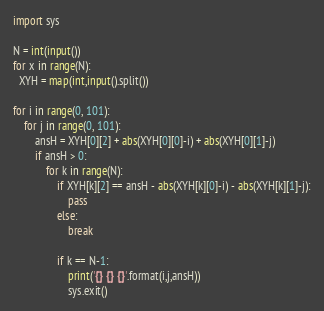Convert code to text. <code><loc_0><loc_0><loc_500><loc_500><_Python_>import sys
 
N = int(input())
for x in range(N):
  XYH = map(int,input().split())
  
for i in range(0, 101):
    for j in range(0, 101):
        ansH = XYH[0][2] + abs(XYH[0][0]-i) + abs(XYH[0][1]-j)
        if ansH > 0:
            for k in range(N):
                if XYH[k][2] == ansH - abs(XYH[k][0]-i) - abs(XYH[k][1]-j):
                    pass
                else:
                    break
 
                if k == N-1:
                    print('{} {} {}'.format(i,j,ansH))
                    sys.exit()</code> 